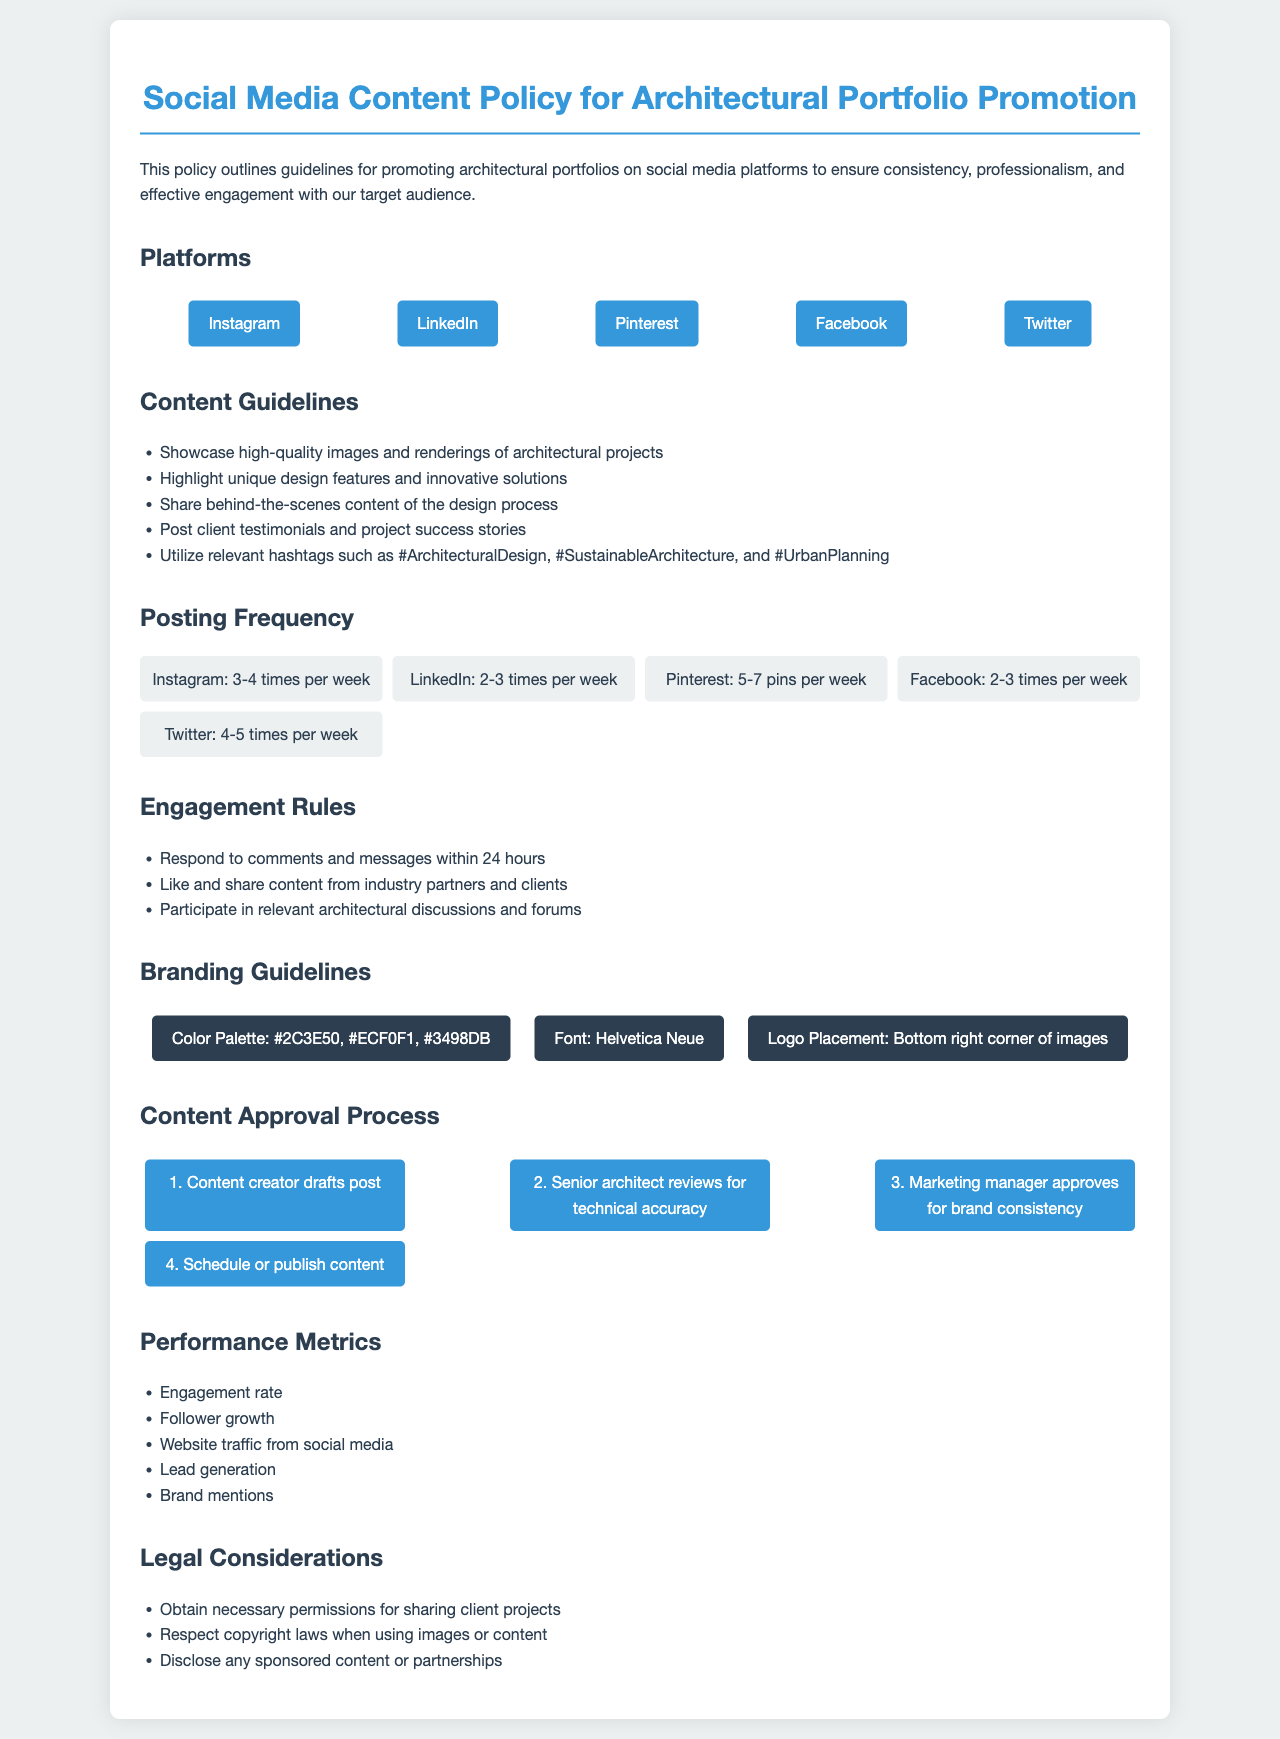What platforms are listed for social media content? The document specifies platforms for social media content promotion including Instagram, LinkedIn, Pinterest, Facebook, and Twitter.
Answer: Instagram, LinkedIn, Pinterest, Facebook, Twitter What is the recommended posting frequency for Instagram? The document states that posts on Instagram should be made 3 to 4 times per week.
Answer: 3-4 times per week What type of content should be showcased according to the guidelines? The guidelines recommend showcasing high-quality images and renderings of architectural projects.
Answer: High-quality images and renderings What is the last step in the content approval process? The document outlines that the last step is to schedule or publish content.
Answer: Schedule or publish content How often should comments and messages be responded to? The policy requires that comments and messages should be responded to within 24 hours.
Answer: Within 24 hours Which color is included in the branding guidelines? The branding guidelines include the color palette which has colors like #2C3E50, #ECF0F1, and #3498DB.
Answer: #2C3E50 What is one of the performance metrics mentioned? The document lists engagement rate, follower growth, website traffic from social media, lead generation, or brand mentions as performance metrics.
Answer: Engagement rate What should be obtained before sharing client projects? The legal considerations in the document state that necessary permissions for sharing client projects should be obtained.
Answer: Necessary permissions 